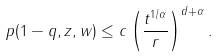Convert formula to latex. <formula><loc_0><loc_0><loc_500><loc_500>p ( 1 - q , z , w ) \leq c \left ( \frac { t ^ { 1 / \alpha } } { r } \right ) ^ { d + \alpha } .</formula> 